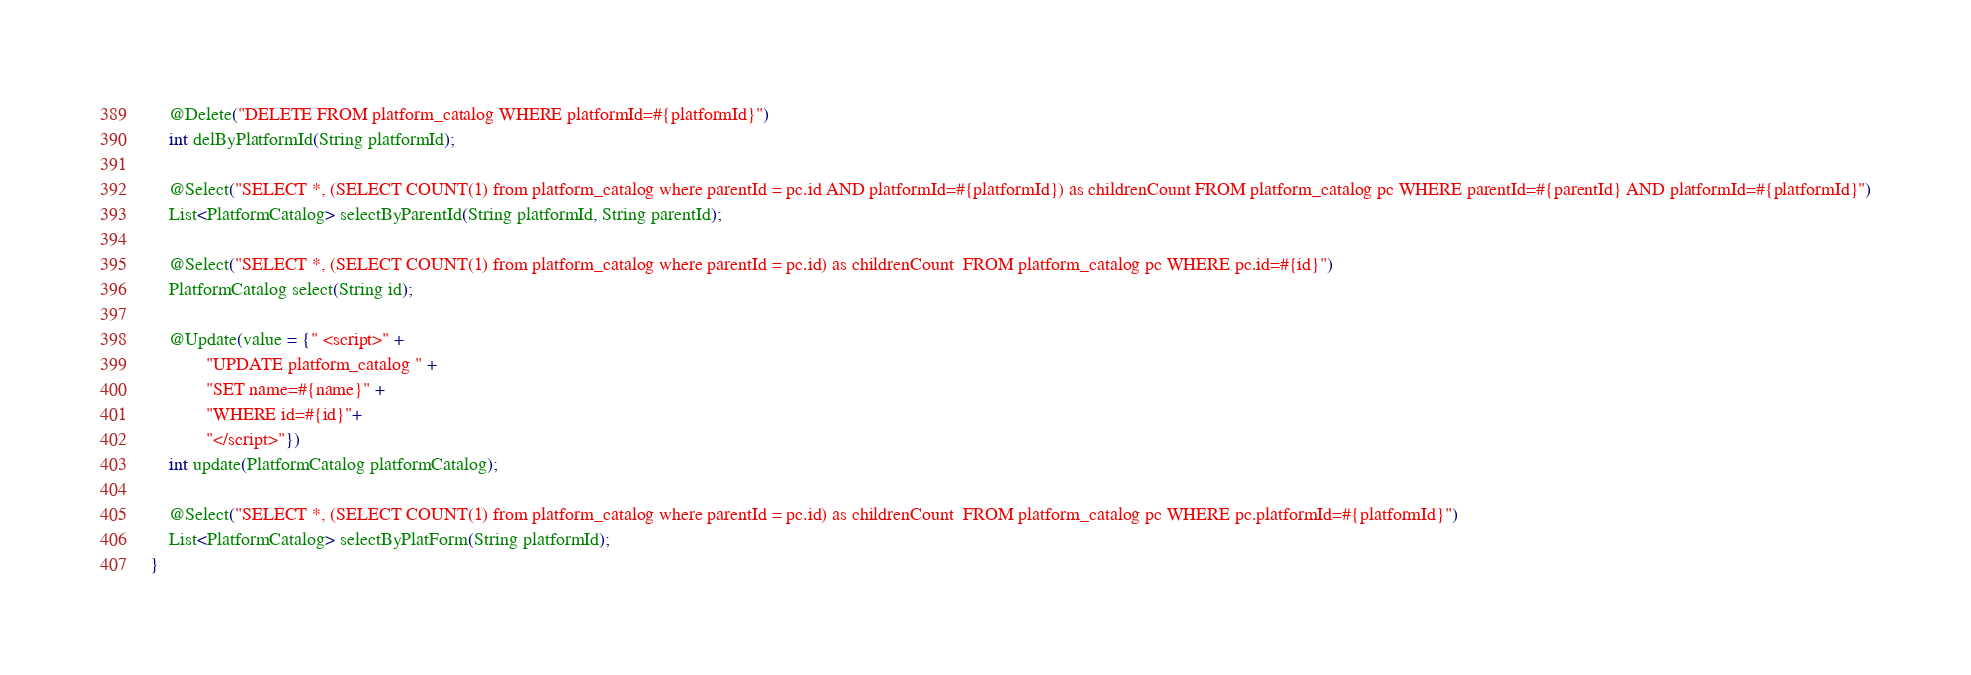Convert code to text. <code><loc_0><loc_0><loc_500><loc_500><_Java_>    @Delete("DELETE FROM platform_catalog WHERE platformId=#{platformId}")
    int delByPlatformId(String platformId);

    @Select("SELECT *, (SELECT COUNT(1) from platform_catalog where parentId = pc.id AND platformId=#{platformId}) as childrenCount FROM platform_catalog pc WHERE parentId=#{parentId} AND platformId=#{platformId}")
    List<PlatformCatalog> selectByParentId(String platformId, String parentId);

    @Select("SELECT *, (SELECT COUNT(1) from platform_catalog where parentId = pc.id) as childrenCount  FROM platform_catalog pc WHERE pc.id=#{id}")
    PlatformCatalog select(String id);

    @Update(value = {" <script>" +
            "UPDATE platform_catalog " +
            "SET name=#{name}" +
            "WHERE id=#{id}"+
            "</script>"})
    int update(PlatformCatalog platformCatalog);

    @Select("SELECT *, (SELECT COUNT(1) from platform_catalog where parentId = pc.id) as childrenCount  FROM platform_catalog pc WHERE pc.platformId=#{platformId}")
    List<PlatformCatalog> selectByPlatForm(String platformId);
}
</code> 